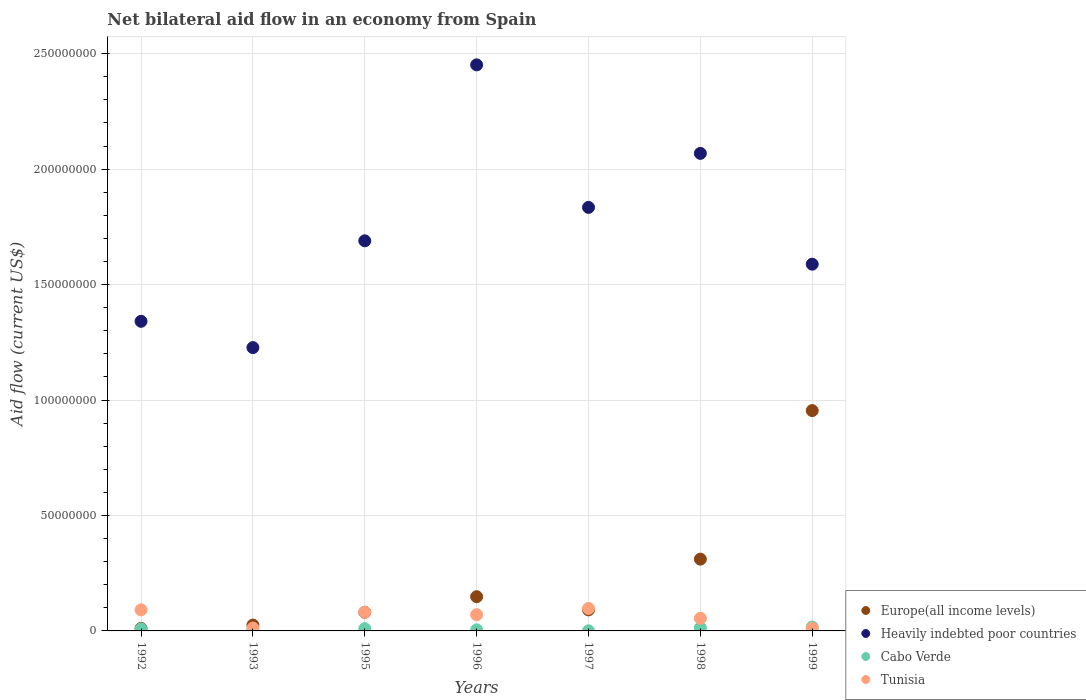How many different coloured dotlines are there?
Your answer should be compact. 4. What is the net bilateral aid flow in Europe(all income levels) in 1998?
Provide a succinct answer. 3.11e+07. Across all years, what is the maximum net bilateral aid flow in Tunisia?
Ensure brevity in your answer.  9.73e+06. Across all years, what is the minimum net bilateral aid flow in Europe(all income levels)?
Make the answer very short. 1.11e+06. In which year was the net bilateral aid flow in Heavily indebted poor countries maximum?
Ensure brevity in your answer.  1996. What is the total net bilateral aid flow in Cabo Verde in the graph?
Your answer should be very brief. 5.86e+06. What is the difference between the net bilateral aid flow in Heavily indebted poor countries in 1993 and that in 1995?
Your answer should be very brief. -4.62e+07. What is the difference between the net bilateral aid flow in Europe(all income levels) in 1993 and the net bilateral aid flow in Tunisia in 1992?
Your response must be concise. -6.59e+06. What is the average net bilateral aid flow in Tunisia per year?
Keep it short and to the point. 5.98e+06. In the year 1997, what is the difference between the net bilateral aid flow in Heavily indebted poor countries and net bilateral aid flow in Tunisia?
Offer a very short reply. 1.74e+08. In how many years, is the net bilateral aid flow in Heavily indebted poor countries greater than 70000000 US$?
Offer a very short reply. 7. What is the ratio of the net bilateral aid flow in Cabo Verde in 1996 to that in 1998?
Make the answer very short. 0.34. Is the difference between the net bilateral aid flow in Heavily indebted poor countries in 1997 and 1998 greater than the difference between the net bilateral aid flow in Tunisia in 1997 and 1998?
Make the answer very short. No. What is the difference between the highest and the second highest net bilateral aid flow in Cabo Verde?
Your answer should be compact. 3.10e+05. What is the difference between the highest and the lowest net bilateral aid flow in Heavily indebted poor countries?
Make the answer very short. 1.22e+08. Is the sum of the net bilateral aid flow in Europe(all income levels) in 1995 and 1996 greater than the maximum net bilateral aid flow in Heavily indebted poor countries across all years?
Offer a very short reply. No. Is it the case that in every year, the sum of the net bilateral aid flow in Heavily indebted poor countries and net bilateral aid flow in Tunisia  is greater than the sum of net bilateral aid flow in Cabo Verde and net bilateral aid flow in Europe(all income levels)?
Your response must be concise. Yes. Is it the case that in every year, the sum of the net bilateral aid flow in Tunisia and net bilateral aid flow in Europe(all income levels)  is greater than the net bilateral aid flow in Cabo Verde?
Your response must be concise. Yes. Does the net bilateral aid flow in Heavily indebted poor countries monotonically increase over the years?
Ensure brevity in your answer.  No. Is the net bilateral aid flow in Heavily indebted poor countries strictly greater than the net bilateral aid flow in Tunisia over the years?
Keep it short and to the point. Yes. How many dotlines are there?
Your answer should be very brief. 4. How many years are there in the graph?
Keep it short and to the point. 7. What is the difference between two consecutive major ticks on the Y-axis?
Ensure brevity in your answer.  5.00e+07. Are the values on the major ticks of Y-axis written in scientific E-notation?
Make the answer very short. No. Does the graph contain any zero values?
Offer a very short reply. No. Does the graph contain grids?
Provide a short and direct response. Yes. What is the title of the graph?
Your response must be concise. Net bilateral aid flow in an economy from Spain. What is the label or title of the Y-axis?
Give a very brief answer. Aid flow (current US$). What is the Aid flow (current US$) of Europe(all income levels) in 1992?
Keep it short and to the point. 1.11e+06. What is the Aid flow (current US$) in Heavily indebted poor countries in 1992?
Your answer should be compact. 1.34e+08. What is the Aid flow (current US$) of Cabo Verde in 1992?
Offer a terse response. 8.80e+05. What is the Aid flow (current US$) in Tunisia in 1992?
Make the answer very short. 9.13e+06. What is the Aid flow (current US$) of Europe(all income levels) in 1993?
Your answer should be very brief. 2.54e+06. What is the Aid flow (current US$) of Heavily indebted poor countries in 1993?
Your answer should be compact. 1.23e+08. What is the Aid flow (current US$) in Tunisia in 1993?
Keep it short and to the point. 1.25e+06. What is the Aid flow (current US$) in Europe(all income levels) in 1995?
Offer a terse response. 8.07e+06. What is the Aid flow (current US$) in Heavily indebted poor countries in 1995?
Offer a very short reply. 1.69e+08. What is the Aid flow (current US$) in Cabo Verde in 1995?
Offer a terse response. 9.90e+05. What is the Aid flow (current US$) of Tunisia in 1995?
Your response must be concise. 8.09e+06. What is the Aid flow (current US$) in Europe(all income levels) in 1996?
Ensure brevity in your answer.  1.48e+07. What is the Aid flow (current US$) of Heavily indebted poor countries in 1996?
Your answer should be very brief. 2.45e+08. What is the Aid flow (current US$) in Tunisia in 1996?
Your answer should be compact. 7.03e+06. What is the Aid flow (current US$) of Europe(all income levels) in 1997?
Make the answer very short. 9.11e+06. What is the Aid flow (current US$) of Heavily indebted poor countries in 1997?
Keep it short and to the point. 1.83e+08. What is the Aid flow (current US$) of Cabo Verde in 1997?
Your answer should be compact. 5.00e+04. What is the Aid flow (current US$) of Tunisia in 1997?
Make the answer very short. 9.73e+06. What is the Aid flow (current US$) of Europe(all income levels) in 1998?
Give a very brief answer. 3.11e+07. What is the Aid flow (current US$) in Heavily indebted poor countries in 1998?
Ensure brevity in your answer.  2.07e+08. What is the Aid flow (current US$) in Cabo Verde in 1998?
Make the answer very short. 1.37e+06. What is the Aid flow (current US$) in Tunisia in 1998?
Offer a terse response. 5.47e+06. What is the Aid flow (current US$) in Europe(all income levels) in 1999?
Provide a short and direct response. 9.54e+07. What is the Aid flow (current US$) in Heavily indebted poor countries in 1999?
Offer a very short reply. 1.59e+08. What is the Aid flow (current US$) of Cabo Verde in 1999?
Keep it short and to the point. 1.68e+06. What is the Aid flow (current US$) in Tunisia in 1999?
Make the answer very short. 1.13e+06. Across all years, what is the maximum Aid flow (current US$) of Europe(all income levels)?
Keep it short and to the point. 9.54e+07. Across all years, what is the maximum Aid flow (current US$) of Heavily indebted poor countries?
Make the answer very short. 2.45e+08. Across all years, what is the maximum Aid flow (current US$) of Cabo Verde?
Make the answer very short. 1.68e+06. Across all years, what is the maximum Aid flow (current US$) in Tunisia?
Your answer should be very brief. 9.73e+06. Across all years, what is the minimum Aid flow (current US$) in Europe(all income levels)?
Your response must be concise. 1.11e+06. Across all years, what is the minimum Aid flow (current US$) of Heavily indebted poor countries?
Make the answer very short. 1.23e+08. Across all years, what is the minimum Aid flow (current US$) of Tunisia?
Your answer should be compact. 1.13e+06. What is the total Aid flow (current US$) of Europe(all income levels) in the graph?
Offer a very short reply. 1.62e+08. What is the total Aid flow (current US$) of Heavily indebted poor countries in the graph?
Ensure brevity in your answer.  1.22e+09. What is the total Aid flow (current US$) in Cabo Verde in the graph?
Keep it short and to the point. 5.86e+06. What is the total Aid flow (current US$) in Tunisia in the graph?
Give a very brief answer. 4.18e+07. What is the difference between the Aid flow (current US$) in Europe(all income levels) in 1992 and that in 1993?
Your response must be concise. -1.43e+06. What is the difference between the Aid flow (current US$) in Heavily indebted poor countries in 1992 and that in 1993?
Your answer should be very brief. 1.14e+07. What is the difference between the Aid flow (current US$) in Cabo Verde in 1992 and that in 1993?
Offer a terse response. 4.50e+05. What is the difference between the Aid flow (current US$) in Tunisia in 1992 and that in 1993?
Your answer should be very brief. 7.88e+06. What is the difference between the Aid flow (current US$) of Europe(all income levels) in 1992 and that in 1995?
Keep it short and to the point. -6.96e+06. What is the difference between the Aid flow (current US$) of Heavily indebted poor countries in 1992 and that in 1995?
Give a very brief answer. -3.49e+07. What is the difference between the Aid flow (current US$) in Tunisia in 1992 and that in 1995?
Offer a very short reply. 1.04e+06. What is the difference between the Aid flow (current US$) of Europe(all income levels) in 1992 and that in 1996?
Your answer should be very brief. -1.37e+07. What is the difference between the Aid flow (current US$) of Heavily indebted poor countries in 1992 and that in 1996?
Provide a succinct answer. -1.11e+08. What is the difference between the Aid flow (current US$) of Cabo Verde in 1992 and that in 1996?
Offer a terse response. 4.20e+05. What is the difference between the Aid flow (current US$) in Tunisia in 1992 and that in 1996?
Make the answer very short. 2.10e+06. What is the difference between the Aid flow (current US$) in Europe(all income levels) in 1992 and that in 1997?
Your response must be concise. -8.00e+06. What is the difference between the Aid flow (current US$) of Heavily indebted poor countries in 1992 and that in 1997?
Your response must be concise. -4.93e+07. What is the difference between the Aid flow (current US$) in Cabo Verde in 1992 and that in 1997?
Give a very brief answer. 8.30e+05. What is the difference between the Aid flow (current US$) of Tunisia in 1992 and that in 1997?
Provide a short and direct response. -6.00e+05. What is the difference between the Aid flow (current US$) in Europe(all income levels) in 1992 and that in 1998?
Ensure brevity in your answer.  -3.00e+07. What is the difference between the Aid flow (current US$) of Heavily indebted poor countries in 1992 and that in 1998?
Your answer should be very brief. -7.27e+07. What is the difference between the Aid flow (current US$) in Cabo Verde in 1992 and that in 1998?
Your response must be concise. -4.90e+05. What is the difference between the Aid flow (current US$) of Tunisia in 1992 and that in 1998?
Your response must be concise. 3.66e+06. What is the difference between the Aid flow (current US$) in Europe(all income levels) in 1992 and that in 1999?
Provide a succinct answer. -9.43e+07. What is the difference between the Aid flow (current US$) in Heavily indebted poor countries in 1992 and that in 1999?
Give a very brief answer. -2.47e+07. What is the difference between the Aid flow (current US$) of Cabo Verde in 1992 and that in 1999?
Make the answer very short. -8.00e+05. What is the difference between the Aid flow (current US$) of Europe(all income levels) in 1993 and that in 1995?
Your answer should be very brief. -5.53e+06. What is the difference between the Aid flow (current US$) of Heavily indebted poor countries in 1993 and that in 1995?
Give a very brief answer. -4.62e+07. What is the difference between the Aid flow (current US$) of Cabo Verde in 1993 and that in 1995?
Provide a short and direct response. -5.60e+05. What is the difference between the Aid flow (current US$) in Tunisia in 1993 and that in 1995?
Offer a very short reply. -6.84e+06. What is the difference between the Aid flow (current US$) in Europe(all income levels) in 1993 and that in 1996?
Your response must be concise. -1.23e+07. What is the difference between the Aid flow (current US$) of Heavily indebted poor countries in 1993 and that in 1996?
Offer a terse response. -1.22e+08. What is the difference between the Aid flow (current US$) of Cabo Verde in 1993 and that in 1996?
Provide a short and direct response. -3.00e+04. What is the difference between the Aid flow (current US$) of Tunisia in 1993 and that in 1996?
Your answer should be very brief. -5.78e+06. What is the difference between the Aid flow (current US$) in Europe(all income levels) in 1993 and that in 1997?
Make the answer very short. -6.57e+06. What is the difference between the Aid flow (current US$) of Heavily indebted poor countries in 1993 and that in 1997?
Your response must be concise. -6.07e+07. What is the difference between the Aid flow (current US$) of Cabo Verde in 1993 and that in 1997?
Offer a very short reply. 3.80e+05. What is the difference between the Aid flow (current US$) in Tunisia in 1993 and that in 1997?
Your answer should be compact. -8.48e+06. What is the difference between the Aid flow (current US$) of Europe(all income levels) in 1993 and that in 1998?
Provide a succinct answer. -2.86e+07. What is the difference between the Aid flow (current US$) in Heavily indebted poor countries in 1993 and that in 1998?
Provide a short and direct response. -8.41e+07. What is the difference between the Aid flow (current US$) in Cabo Verde in 1993 and that in 1998?
Provide a short and direct response. -9.40e+05. What is the difference between the Aid flow (current US$) of Tunisia in 1993 and that in 1998?
Ensure brevity in your answer.  -4.22e+06. What is the difference between the Aid flow (current US$) of Europe(all income levels) in 1993 and that in 1999?
Offer a terse response. -9.29e+07. What is the difference between the Aid flow (current US$) of Heavily indebted poor countries in 1993 and that in 1999?
Ensure brevity in your answer.  -3.61e+07. What is the difference between the Aid flow (current US$) in Cabo Verde in 1993 and that in 1999?
Give a very brief answer. -1.25e+06. What is the difference between the Aid flow (current US$) in Europe(all income levels) in 1995 and that in 1996?
Your answer should be very brief. -6.76e+06. What is the difference between the Aid flow (current US$) of Heavily indebted poor countries in 1995 and that in 1996?
Ensure brevity in your answer.  -7.62e+07. What is the difference between the Aid flow (current US$) of Cabo Verde in 1995 and that in 1996?
Keep it short and to the point. 5.30e+05. What is the difference between the Aid flow (current US$) of Tunisia in 1995 and that in 1996?
Your response must be concise. 1.06e+06. What is the difference between the Aid flow (current US$) of Europe(all income levels) in 1995 and that in 1997?
Provide a short and direct response. -1.04e+06. What is the difference between the Aid flow (current US$) in Heavily indebted poor countries in 1995 and that in 1997?
Provide a succinct answer. -1.45e+07. What is the difference between the Aid flow (current US$) of Cabo Verde in 1995 and that in 1997?
Your response must be concise. 9.40e+05. What is the difference between the Aid flow (current US$) of Tunisia in 1995 and that in 1997?
Your answer should be very brief. -1.64e+06. What is the difference between the Aid flow (current US$) in Europe(all income levels) in 1995 and that in 1998?
Make the answer very short. -2.30e+07. What is the difference between the Aid flow (current US$) of Heavily indebted poor countries in 1995 and that in 1998?
Provide a short and direct response. -3.79e+07. What is the difference between the Aid flow (current US$) of Cabo Verde in 1995 and that in 1998?
Your answer should be very brief. -3.80e+05. What is the difference between the Aid flow (current US$) in Tunisia in 1995 and that in 1998?
Keep it short and to the point. 2.62e+06. What is the difference between the Aid flow (current US$) of Europe(all income levels) in 1995 and that in 1999?
Provide a succinct answer. -8.74e+07. What is the difference between the Aid flow (current US$) in Heavily indebted poor countries in 1995 and that in 1999?
Your answer should be compact. 1.01e+07. What is the difference between the Aid flow (current US$) in Cabo Verde in 1995 and that in 1999?
Provide a succinct answer. -6.90e+05. What is the difference between the Aid flow (current US$) in Tunisia in 1995 and that in 1999?
Your answer should be compact. 6.96e+06. What is the difference between the Aid flow (current US$) of Europe(all income levels) in 1996 and that in 1997?
Provide a succinct answer. 5.72e+06. What is the difference between the Aid flow (current US$) in Heavily indebted poor countries in 1996 and that in 1997?
Your answer should be compact. 6.17e+07. What is the difference between the Aid flow (current US$) of Cabo Verde in 1996 and that in 1997?
Your answer should be very brief. 4.10e+05. What is the difference between the Aid flow (current US$) of Tunisia in 1996 and that in 1997?
Your answer should be very brief. -2.70e+06. What is the difference between the Aid flow (current US$) of Europe(all income levels) in 1996 and that in 1998?
Offer a terse response. -1.63e+07. What is the difference between the Aid flow (current US$) in Heavily indebted poor countries in 1996 and that in 1998?
Keep it short and to the point. 3.83e+07. What is the difference between the Aid flow (current US$) in Cabo Verde in 1996 and that in 1998?
Your response must be concise. -9.10e+05. What is the difference between the Aid flow (current US$) of Tunisia in 1996 and that in 1998?
Make the answer very short. 1.56e+06. What is the difference between the Aid flow (current US$) in Europe(all income levels) in 1996 and that in 1999?
Keep it short and to the point. -8.06e+07. What is the difference between the Aid flow (current US$) of Heavily indebted poor countries in 1996 and that in 1999?
Keep it short and to the point. 8.63e+07. What is the difference between the Aid flow (current US$) of Cabo Verde in 1996 and that in 1999?
Provide a short and direct response. -1.22e+06. What is the difference between the Aid flow (current US$) in Tunisia in 1996 and that in 1999?
Provide a succinct answer. 5.90e+06. What is the difference between the Aid flow (current US$) of Europe(all income levels) in 1997 and that in 1998?
Your answer should be compact. -2.20e+07. What is the difference between the Aid flow (current US$) in Heavily indebted poor countries in 1997 and that in 1998?
Give a very brief answer. -2.34e+07. What is the difference between the Aid flow (current US$) in Cabo Verde in 1997 and that in 1998?
Offer a very short reply. -1.32e+06. What is the difference between the Aid flow (current US$) of Tunisia in 1997 and that in 1998?
Your answer should be compact. 4.26e+06. What is the difference between the Aid flow (current US$) in Europe(all income levels) in 1997 and that in 1999?
Provide a short and direct response. -8.63e+07. What is the difference between the Aid flow (current US$) in Heavily indebted poor countries in 1997 and that in 1999?
Keep it short and to the point. 2.46e+07. What is the difference between the Aid flow (current US$) of Cabo Verde in 1997 and that in 1999?
Ensure brevity in your answer.  -1.63e+06. What is the difference between the Aid flow (current US$) in Tunisia in 1997 and that in 1999?
Your response must be concise. 8.60e+06. What is the difference between the Aid flow (current US$) of Europe(all income levels) in 1998 and that in 1999?
Give a very brief answer. -6.43e+07. What is the difference between the Aid flow (current US$) of Heavily indebted poor countries in 1998 and that in 1999?
Keep it short and to the point. 4.80e+07. What is the difference between the Aid flow (current US$) in Cabo Verde in 1998 and that in 1999?
Ensure brevity in your answer.  -3.10e+05. What is the difference between the Aid flow (current US$) in Tunisia in 1998 and that in 1999?
Give a very brief answer. 4.34e+06. What is the difference between the Aid flow (current US$) of Europe(all income levels) in 1992 and the Aid flow (current US$) of Heavily indebted poor countries in 1993?
Your answer should be compact. -1.22e+08. What is the difference between the Aid flow (current US$) in Europe(all income levels) in 1992 and the Aid flow (current US$) in Cabo Verde in 1993?
Offer a terse response. 6.80e+05. What is the difference between the Aid flow (current US$) in Heavily indebted poor countries in 1992 and the Aid flow (current US$) in Cabo Verde in 1993?
Offer a terse response. 1.34e+08. What is the difference between the Aid flow (current US$) in Heavily indebted poor countries in 1992 and the Aid flow (current US$) in Tunisia in 1993?
Your response must be concise. 1.33e+08. What is the difference between the Aid flow (current US$) in Cabo Verde in 1992 and the Aid flow (current US$) in Tunisia in 1993?
Offer a terse response. -3.70e+05. What is the difference between the Aid flow (current US$) of Europe(all income levels) in 1992 and the Aid flow (current US$) of Heavily indebted poor countries in 1995?
Your answer should be very brief. -1.68e+08. What is the difference between the Aid flow (current US$) of Europe(all income levels) in 1992 and the Aid flow (current US$) of Cabo Verde in 1995?
Offer a terse response. 1.20e+05. What is the difference between the Aid flow (current US$) of Europe(all income levels) in 1992 and the Aid flow (current US$) of Tunisia in 1995?
Your response must be concise. -6.98e+06. What is the difference between the Aid flow (current US$) in Heavily indebted poor countries in 1992 and the Aid flow (current US$) in Cabo Verde in 1995?
Give a very brief answer. 1.33e+08. What is the difference between the Aid flow (current US$) of Heavily indebted poor countries in 1992 and the Aid flow (current US$) of Tunisia in 1995?
Your answer should be compact. 1.26e+08. What is the difference between the Aid flow (current US$) of Cabo Verde in 1992 and the Aid flow (current US$) of Tunisia in 1995?
Give a very brief answer. -7.21e+06. What is the difference between the Aid flow (current US$) in Europe(all income levels) in 1992 and the Aid flow (current US$) in Heavily indebted poor countries in 1996?
Make the answer very short. -2.44e+08. What is the difference between the Aid flow (current US$) of Europe(all income levels) in 1992 and the Aid flow (current US$) of Cabo Verde in 1996?
Your response must be concise. 6.50e+05. What is the difference between the Aid flow (current US$) of Europe(all income levels) in 1992 and the Aid flow (current US$) of Tunisia in 1996?
Your answer should be compact. -5.92e+06. What is the difference between the Aid flow (current US$) of Heavily indebted poor countries in 1992 and the Aid flow (current US$) of Cabo Verde in 1996?
Provide a succinct answer. 1.34e+08. What is the difference between the Aid flow (current US$) in Heavily indebted poor countries in 1992 and the Aid flow (current US$) in Tunisia in 1996?
Your response must be concise. 1.27e+08. What is the difference between the Aid flow (current US$) of Cabo Verde in 1992 and the Aid flow (current US$) of Tunisia in 1996?
Provide a short and direct response. -6.15e+06. What is the difference between the Aid flow (current US$) of Europe(all income levels) in 1992 and the Aid flow (current US$) of Heavily indebted poor countries in 1997?
Give a very brief answer. -1.82e+08. What is the difference between the Aid flow (current US$) in Europe(all income levels) in 1992 and the Aid flow (current US$) in Cabo Verde in 1997?
Make the answer very short. 1.06e+06. What is the difference between the Aid flow (current US$) of Europe(all income levels) in 1992 and the Aid flow (current US$) of Tunisia in 1997?
Provide a succinct answer. -8.62e+06. What is the difference between the Aid flow (current US$) of Heavily indebted poor countries in 1992 and the Aid flow (current US$) of Cabo Verde in 1997?
Offer a terse response. 1.34e+08. What is the difference between the Aid flow (current US$) in Heavily indebted poor countries in 1992 and the Aid flow (current US$) in Tunisia in 1997?
Offer a very short reply. 1.24e+08. What is the difference between the Aid flow (current US$) of Cabo Verde in 1992 and the Aid flow (current US$) of Tunisia in 1997?
Provide a succinct answer. -8.85e+06. What is the difference between the Aid flow (current US$) of Europe(all income levels) in 1992 and the Aid flow (current US$) of Heavily indebted poor countries in 1998?
Give a very brief answer. -2.06e+08. What is the difference between the Aid flow (current US$) in Europe(all income levels) in 1992 and the Aid flow (current US$) in Tunisia in 1998?
Provide a succinct answer. -4.36e+06. What is the difference between the Aid flow (current US$) in Heavily indebted poor countries in 1992 and the Aid flow (current US$) in Cabo Verde in 1998?
Provide a succinct answer. 1.33e+08. What is the difference between the Aid flow (current US$) of Heavily indebted poor countries in 1992 and the Aid flow (current US$) of Tunisia in 1998?
Provide a succinct answer. 1.29e+08. What is the difference between the Aid flow (current US$) of Cabo Verde in 1992 and the Aid flow (current US$) of Tunisia in 1998?
Provide a succinct answer. -4.59e+06. What is the difference between the Aid flow (current US$) in Europe(all income levels) in 1992 and the Aid flow (current US$) in Heavily indebted poor countries in 1999?
Give a very brief answer. -1.58e+08. What is the difference between the Aid flow (current US$) in Europe(all income levels) in 1992 and the Aid flow (current US$) in Cabo Verde in 1999?
Provide a short and direct response. -5.70e+05. What is the difference between the Aid flow (current US$) in Heavily indebted poor countries in 1992 and the Aid flow (current US$) in Cabo Verde in 1999?
Make the answer very short. 1.32e+08. What is the difference between the Aid flow (current US$) of Heavily indebted poor countries in 1992 and the Aid flow (current US$) of Tunisia in 1999?
Provide a succinct answer. 1.33e+08. What is the difference between the Aid flow (current US$) in Cabo Verde in 1992 and the Aid flow (current US$) in Tunisia in 1999?
Give a very brief answer. -2.50e+05. What is the difference between the Aid flow (current US$) of Europe(all income levels) in 1993 and the Aid flow (current US$) of Heavily indebted poor countries in 1995?
Offer a very short reply. -1.66e+08. What is the difference between the Aid flow (current US$) of Europe(all income levels) in 1993 and the Aid flow (current US$) of Cabo Verde in 1995?
Your answer should be compact. 1.55e+06. What is the difference between the Aid flow (current US$) of Europe(all income levels) in 1993 and the Aid flow (current US$) of Tunisia in 1995?
Offer a terse response. -5.55e+06. What is the difference between the Aid flow (current US$) of Heavily indebted poor countries in 1993 and the Aid flow (current US$) of Cabo Verde in 1995?
Provide a succinct answer. 1.22e+08. What is the difference between the Aid flow (current US$) in Heavily indebted poor countries in 1993 and the Aid flow (current US$) in Tunisia in 1995?
Ensure brevity in your answer.  1.15e+08. What is the difference between the Aid flow (current US$) in Cabo Verde in 1993 and the Aid flow (current US$) in Tunisia in 1995?
Offer a very short reply. -7.66e+06. What is the difference between the Aid flow (current US$) in Europe(all income levels) in 1993 and the Aid flow (current US$) in Heavily indebted poor countries in 1996?
Make the answer very short. -2.43e+08. What is the difference between the Aid flow (current US$) of Europe(all income levels) in 1993 and the Aid flow (current US$) of Cabo Verde in 1996?
Provide a short and direct response. 2.08e+06. What is the difference between the Aid flow (current US$) in Europe(all income levels) in 1993 and the Aid flow (current US$) in Tunisia in 1996?
Your response must be concise. -4.49e+06. What is the difference between the Aid flow (current US$) in Heavily indebted poor countries in 1993 and the Aid flow (current US$) in Cabo Verde in 1996?
Offer a very short reply. 1.22e+08. What is the difference between the Aid flow (current US$) in Heavily indebted poor countries in 1993 and the Aid flow (current US$) in Tunisia in 1996?
Your answer should be compact. 1.16e+08. What is the difference between the Aid flow (current US$) in Cabo Verde in 1993 and the Aid flow (current US$) in Tunisia in 1996?
Provide a short and direct response. -6.60e+06. What is the difference between the Aid flow (current US$) of Europe(all income levels) in 1993 and the Aid flow (current US$) of Heavily indebted poor countries in 1997?
Ensure brevity in your answer.  -1.81e+08. What is the difference between the Aid flow (current US$) in Europe(all income levels) in 1993 and the Aid flow (current US$) in Cabo Verde in 1997?
Ensure brevity in your answer.  2.49e+06. What is the difference between the Aid flow (current US$) of Europe(all income levels) in 1993 and the Aid flow (current US$) of Tunisia in 1997?
Keep it short and to the point. -7.19e+06. What is the difference between the Aid flow (current US$) of Heavily indebted poor countries in 1993 and the Aid flow (current US$) of Cabo Verde in 1997?
Offer a very short reply. 1.23e+08. What is the difference between the Aid flow (current US$) of Heavily indebted poor countries in 1993 and the Aid flow (current US$) of Tunisia in 1997?
Offer a very short reply. 1.13e+08. What is the difference between the Aid flow (current US$) of Cabo Verde in 1993 and the Aid flow (current US$) of Tunisia in 1997?
Ensure brevity in your answer.  -9.30e+06. What is the difference between the Aid flow (current US$) of Europe(all income levels) in 1993 and the Aid flow (current US$) of Heavily indebted poor countries in 1998?
Offer a terse response. -2.04e+08. What is the difference between the Aid flow (current US$) of Europe(all income levels) in 1993 and the Aid flow (current US$) of Cabo Verde in 1998?
Give a very brief answer. 1.17e+06. What is the difference between the Aid flow (current US$) of Europe(all income levels) in 1993 and the Aid flow (current US$) of Tunisia in 1998?
Ensure brevity in your answer.  -2.93e+06. What is the difference between the Aid flow (current US$) in Heavily indebted poor countries in 1993 and the Aid flow (current US$) in Cabo Verde in 1998?
Provide a short and direct response. 1.21e+08. What is the difference between the Aid flow (current US$) of Heavily indebted poor countries in 1993 and the Aid flow (current US$) of Tunisia in 1998?
Offer a very short reply. 1.17e+08. What is the difference between the Aid flow (current US$) in Cabo Verde in 1993 and the Aid flow (current US$) in Tunisia in 1998?
Your answer should be very brief. -5.04e+06. What is the difference between the Aid flow (current US$) of Europe(all income levels) in 1993 and the Aid flow (current US$) of Heavily indebted poor countries in 1999?
Your answer should be compact. -1.56e+08. What is the difference between the Aid flow (current US$) in Europe(all income levels) in 1993 and the Aid flow (current US$) in Cabo Verde in 1999?
Provide a short and direct response. 8.60e+05. What is the difference between the Aid flow (current US$) of Europe(all income levels) in 1993 and the Aid flow (current US$) of Tunisia in 1999?
Provide a succinct answer. 1.41e+06. What is the difference between the Aid flow (current US$) of Heavily indebted poor countries in 1993 and the Aid flow (current US$) of Cabo Verde in 1999?
Give a very brief answer. 1.21e+08. What is the difference between the Aid flow (current US$) of Heavily indebted poor countries in 1993 and the Aid flow (current US$) of Tunisia in 1999?
Provide a succinct answer. 1.22e+08. What is the difference between the Aid flow (current US$) of Cabo Verde in 1993 and the Aid flow (current US$) of Tunisia in 1999?
Make the answer very short. -7.00e+05. What is the difference between the Aid flow (current US$) of Europe(all income levels) in 1995 and the Aid flow (current US$) of Heavily indebted poor countries in 1996?
Keep it short and to the point. -2.37e+08. What is the difference between the Aid flow (current US$) of Europe(all income levels) in 1995 and the Aid flow (current US$) of Cabo Verde in 1996?
Provide a short and direct response. 7.61e+06. What is the difference between the Aid flow (current US$) in Europe(all income levels) in 1995 and the Aid flow (current US$) in Tunisia in 1996?
Offer a terse response. 1.04e+06. What is the difference between the Aid flow (current US$) of Heavily indebted poor countries in 1995 and the Aid flow (current US$) of Cabo Verde in 1996?
Make the answer very short. 1.68e+08. What is the difference between the Aid flow (current US$) of Heavily indebted poor countries in 1995 and the Aid flow (current US$) of Tunisia in 1996?
Offer a terse response. 1.62e+08. What is the difference between the Aid flow (current US$) of Cabo Verde in 1995 and the Aid flow (current US$) of Tunisia in 1996?
Provide a succinct answer. -6.04e+06. What is the difference between the Aid flow (current US$) of Europe(all income levels) in 1995 and the Aid flow (current US$) of Heavily indebted poor countries in 1997?
Offer a terse response. -1.75e+08. What is the difference between the Aid flow (current US$) of Europe(all income levels) in 1995 and the Aid flow (current US$) of Cabo Verde in 1997?
Your answer should be compact. 8.02e+06. What is the difference between the Aid flow (current US$) in Europe(all income levels) in 1995 and the Aid flow (current US$) in Tunisia in 1997?
Your answer should be very brief. -1.66e+06. What is the difference between the Aid flow (current US$) of Heavily indebted poor countries in 1995 and the Aid flow (current US$) of Cabo Verde in 1997?
Make the answer very short. 1.69e+08. What is the difference between the Aid flow (current US$) of Heavily indebted poor countries in 1995 and the Aid flow (current US$) of Tunisia in 1997?
Your answer should be compact. 1.59e+08. What is the difference between the Aid flow (current US$) of Cabo Verde in 1995 and the Aid flow (current US$) of Tunisia in 1997?
Keep it short and to the point. -8.74e+06. What is the difference between the Aid flow (current US$) in Europe(all income levels) in 1995 and the Aid flow (current US$) in Heavily indebted poor countries in 1998?
Your answer should be compact. -1.99e+08. What is the difference between the Aid flow (current US$) in Europe(all income levels) in 1995 and the Aid flow (current US$) in Cabo Verde in 1998?
Make the answer very short. 6.70e+06. What is the difference between the Aid flow (current US$) of Europe(all income levels) in 1995 and the Aid flow (current US$) of Tunisia in 1998?
Offer a terse response. 2.60e+06. What is the difference between the Aid flow (current US$) in Heavily indebted poor countries in 1995 and the Aid flow (current US$) in Cabo Verde in 1998?
Offer a terse response. 1.68e+08. What is the difference between the Aid flow (current US$) of Heavily indebted poor countries in 1995 and the Aid flow (current US$) of Tunisia in 1998?
Keep it short and to the point. 1.63e+08. What is the difference between the Aid flow (current US$) in Cabo Verde in 1995 and the Aid flow (current US$) in Tunisia in 1998?
Offer a terse response. -4.48e+06. What is the difference between the Aid flow (current US$) in Europe(all income levels) in 1995 and the Aid flow (current US$) in Heavily indebted poor countries in 1999?
Offer a terse response. -1.51e+08. What is the difference between the Aid flow (current US$) in Europe(all income levels) in 1995 and the Aid flow (current US$) in Cabo Verde in 1999?
Offer a terse response. 6.39e+06. What is the difference between the Aid flow (current US$) of Europe(all income levels) in 1995 and the Aid flow (current US$) of Tunisia in 1999?
Make the answer very short. 6.94e+06. What is the difference between the Aid flow (current US$) of Heavily indebted poor countries in 1995 and the Aid flow (current US$) of Cabo Verde in 1999?
Your response must be concise. 1.67e+08. What is the difference between the Aid flow (current US$) of Heavily indebted poor countries in 1995 and the Aid flow (current US$) of Tunisia in 1999?
Your answer should be compact. 1.68e+08. What is the difference between the Aid flow (current US$) of Cabo Verde in 1995 and the Aid flow (current US$) of Tunisia in 1999?
Keep it short and to the point. -1.40e+05. What is the difference between the Aid flow (current US$) of Europe(all income levels) in 1996 and the Aid flow (current US$) of Heavily indebted poor countries in 1997?
Make the answer very short. -1.69e+08. What is the difference between the Aid flow (current US$) in Europe(all income levels) in 1996 and the Aid flow (current US$) in Cabo Verde in 1997?
Provide a succinct answer. 1.48e+07. What is the difference between the Aid flow (current US$) of Europe(all income levels) in 1996 and the Aid flow (current US$) of Tunisia in 1997?
Keep it short and to the point. 5.10e+06. What is the difference between the Aid flow (current US$) of Heavily indebted poor countries in 1996 and the Aid flow (current US$) of Cabo Verde in 1997?
Provide a succinct answer. 2.45e+08. What is the difference between the Aid flow (current US$) in Heavily indebted poor countries in 1996 and the Aid flow (current US$) in Tunisia in 1997?
Keep it short and to the point. 2.35e+08. What is the difference between the Aid flow (current US$) in Cabo Verde in 1996 and the Aid flow (current US$) in Tunisia in 1997?
Give a very brief answer. -9.27e+06. What is the difference between the Aid flow (current US$) of Europe(all income levels) in 1996 and the Aid flow (current US$) of Heavily indebted poor countries in 1998?
Your answer should be compact. -1.92e+08. What is the difference between the Aid flow (current US$) in Europe(all income levels) in 1996 and the Aid flow (current US$) in Cabo Verde in 1998?
Your answer should be compact. 1.35e+07. What is the difference between the Aid flow (current US$) in Europe(all income levels) in 1996 and the Aid flow (current US$) in Tunisia in 1998?
Offer a very short reply. 9.36e+06. What is the difference between the Aid flow (current US$) of Heavily indebted poor countries in 1996 and the Aid flow (current US$) of Cabo Verde in 1998?
Your response must be concise. 2.44e+08. What is the difference between the Aid flow (current US$) of Heavily indebted poor countries in 1996 and the Aid flow (current US$) of Tunisia in 1998?
Offer a terse response. 2.40e+08. What is the difference between the Aid flow (current US$) of Cabo Verde in 1996 and the Aid flow (current US$) of Tunisia in 1998?
Provide a succinct answer. -5.01e+06. What is the difference between the Aid flow (current US$) of Europe(all income levels) in 1996 and the Aid flow (current US$) of Heavily indebted poor countries in 1999?
Make the answer very short. -1.44e+08. What is the difference between the Aid flow (current US$) in Europe(all income levels) in 1996 and the Aid flow (current US$) in Cabo Verde in 1999?
Your answer should be very brief. 1.32e+07. What is the difference between the Aid flow (current US$) of Europe(all income levels) in 1996 and the Aid flow (current US$) of Tunisia in 1999?
Provide a short and direct response. 1.37e+07. What is the difference between the Aid flow (current US$) of Heavily indebted poor countries in 1996 and the Aid flow (current US$) of Cabo Verde in 1999?
Give a very brief answer. 2.43e+08. What is the difference between the Aid flow (current US$) of Heavily indebted poor countries in 1996 and the Aid flow (current US$) of Tunisia in 1999?
Offer a terse response. 2.44e+08. What is the difference between the Aid flow (current US$) in Cabo Verde in 1996 and the Aid flow (current US$) in Tunisia in 1999?
Make the answer very short. -6.70e+05. What is the difference between the Aid flow (current US$) of Europe(all income levels) in 1997 and the Aid flow (current US$) of Heavily indebted poor countries in 1998?
Offer a terse response. -1.98e+08. What is the difference between the Aid flow (current US$) in Europe(all income levels) in 1997 and the Aid flow (current US$) in Cabo Verde in 1998?
Give a very brief answer. 7.74e+06. What is the difference between the Aid flow (current US$) of Europe(all income levels) in 1997 and the Aid flow (current US$) of Tunisia in 1998?
Make the answer very short. 3.64e+06. What is the difference between the Aid flow (current US$) of Heavily indebted poor countries in 1997 and the Aid flow (current US$) of Cabo Verde in 1998?
Your answer should be very brief. 1.82e+08. What is the difference between the Aid flow (current US$) in Heavily indebted poor countries in 1997 and the Aid flow (current US$) in Tunisia in 1998?
Offer a terse response. 1.78e+08. What is the difference between the Aid flow (current US$) of Cabo Verde in 1997 and the Aid flow (current US$) of Tunisia in 1998?
Ensure brevity in your answer.  -5.42e+06. What is the difference between the Aid flow (current US$) in Europe(all income levels) in 1997 and the Aid flow (current US$) in Heavily indebted poor countries in 1999?
Keep it short and to the point. -1.50e+08. What is the difference between the Aid flow (current US$) in Europe(all income levels) in 1997 and the Aid flow (current US$) in Cabo Verde in 1999?
Give a very brief answer. 7.43e+06. What is the difference between the Aid flow (current US$) in Europe(all income levels) in 1997 and the Aid flow (current US$) in Tunisia in 1999?
Provide a succinct answer. 7.98e+06. What is the difference between the Aid flow (current US$) in Heavily indebted poor countries in 1997 and the Aid flow (current US$) in Cabo Verde in 1999?
Offer a very short reply. 1.82e+08. What is the difference between the Aid flow (current US$) of Heavily indebted poor countries in 1997 and the Aid flow (current US$) of Tunisia in 1999?
Keep it short and to the point. 1.82e+08. What is the difference between the Aid flow (current US$) of Cabo Verde in 1997 and the Aid flow (current US$) of Tunisia in 1999?
Make the answer very short. -1.08e+06. What is the difference between the Aid flow (current US$) of Europe(all income levels) in 1998 and the Aid flow (current US$) of Heavily indebted poor countries in 1999?
Offer a terse response. -1.28e+08. What is the difference between the Aid flow (current US$) in Europe(all income levels) in 1998 and the Aid flow (current US$) in Cabo Verde in 1999?
Offer a terse response. 2.94e+07. What is the difference between the Aid flow (current US$) in Europe(all income levels) in 1998 and the Aid flow (current US$) in Tunisia in 1999?
Ensure brevity in your answer.  3.00e+07. What is the difference between the Aid flow (current US$) of Heavily indebted poor countries in 1998 and the Aid flow (current US$) of Cabo Verde in 1999?
Provide a succinct answer. 2.05e+08. What is the difference between the Aid flow (current US$) in Heavily indebted poor countries in 1998 and the Aid flow (current US$) in Tunisia in 1999?
Offer a terse response. 2.06e+08. What is the difference between the Aid flow (current US$) in Cabo Verde in 1998 and the Aid flow (current US$) in Tunisia in 1999?
Provide a succinct answer. 2.40e+05. What is the average Aid flow (current US$) of Europe(all income levels) per year?
Your response must be concise. 2.32e+07. What is the average Aid flow (current US$) of Heavily indebted poor countries per year?
Give a very brief answer. 1.74e+08. What is the average Aid flow (current US$) in Cabo Verde per year?
Offer a terse response. 8.37e+05. What is the average Aid flow (current US$) of Tunisia per year?
Your response must be concise. 5.98e+06. In the year 1992, what is the difference between the Aid flow (current US$) of Europe(all income levels) and Aid flow (current US$) of Heavily indebted poor countries?
Make the answer very short. -1.33e+08. In the year 1992, what is the difference between the Aid flow (current US$) of Europe(all income levels) and Aid flow (current US$) of Tunisia?
Offer a terse response. -8.02e+06. In the year 1992, what is the difference between the Aid flow (current US$) in Heavily indebted poor countries and Aid flow (current US$) in Cabo Verde?
Offer a terse response. 1.33e+08. In the year 1992, what is the difference between the Aid flow (current US$) of Heavily indebted poor countries and Aid flow (current US$) of Tunisia?
Provide a short and direct response. 1.25e+08. In the year 1992, what is the difference between the Aid flow (current US$) of Cabo Verde and Aid flow (current US$) of Tunisia?
Keep it short and to the point. -8.25e+06. In the year 1993, what is the difference between the Aid flow (current US$) of Europe(all income levels) and Aid flow (current US$) of Heavily indebted poor countries?
Offer a very short reply. -1.20e+08. In the year 1993, what is the difference between the Aid flow (current US$) of Europe(all income levels) and Aid flow (current US$) of Cabo Verde?
Provide a short and direct response. 2.11e+06. In the year 1993, what is the difference between the Aid flow (current US$) of Europe(all income levels) and Aid flow (current US$) of Tunisia?
Your answer should be compact. 1.29e+06. In the year 1993, what is the difference between the Aid flow (current US$) of Heavily indebted poor countries and Aid flow (current US$) of Cabo Verde?
Provide a succinct answer. 1.22e+08. In the year 1993, what is the difference between the Aid flow (current US$) in Heavily indebted poor countries and Aid flow (current US$) in Tunisia?
Your response must be concise. 1.21e+08. In the year 1993, what is the difference between the Aid flow (current US$) of Cabo Verde and Aid flow (current US$) of Tunisia?
Ensure brevity in your answer.  -8.20e+05. In the year 1995, what is the difference between the Aid flow (current US$) of Europe(all income levels) and Aid flow (current US$) of Heavily indebted poor countries?
Ensure brevity in your answer.  -1.61e+08. In the year 1995, what is the difference between the Aid flow (current US$) of Europe(all income levels) and Aid flow (current US$) of Cabo Verde?
Provide a succinct answer. 7.08e+06. In the year 1995, what is the difference between the Aid flow (current US$) of Europe(all income levels) and Aid flow (current US$) of Tunisia?
Make the answer very short. -2.00e+04. In the year 1995, what is the difference between the Aid flow (current US$) in Heavily indebted poor countries and Aid flow (current US$) in Cabo Verde?
Make the answer very short. 1.68e+08. In the year 1995, what is the difference between the Aid flow (current US$) in Heavily indebted poor countries and Aid flow (current US$) in Tunisia?
Keep it short and to the point. 1.61e+08. In the year 1995, what is the difference between the Aid flow (current US$) in Cabo Verde and Aid flow (current US$) in Tunisia?
Offer a very short reply. -7.10e+06. In the year 1996, what is the difference between the Aid flow (current US$) of Europe(all income levels) and Aid flow (current US$) of Heavily indebted poor countries?
Provide a short and direct response. -2.30e+08. In the year 1996, what is the difference between the Aid flow (current US$) of Europe(all income levels) and Aid flow (current US$) of Cabo Verde?
Provide a short and direct response. 1.44e+07. In the year 1996, what is the difference between the Aid flow (current US$) of Europe(all income levels) and Aid flow (current US$) of Tunisia?
Offer a terse response. 7.80e+06. In the year 1996, what is the difference between the Aid flow (current US$) of Heavily indebted poor countries and Aid flow (current US$) of Cabo Verde?
Offer a very short reply. 2.45e+08. In the year 1996, what is the difference between the Aid flow (current US$) in Heavily indebted poor countries and Aid flow (current US$) in Tunisia?
Make the answer very short. 2.38e+08. In the year 1996, what is the difference between the Aid flow (current US$) of Cabo Verde and Aid flow (current US$) of Tunisia?
Ensure brevity in your answer.  -6.57e+06. In the year 1997, what is the difference between the Aid flow (current US$) in Europe(all income levels) and Aid flow (current US$) in Heavily indebted poor countries?
Your response must be concise. -1.74e+08. In the year 1997, what is the difference between the Aid flow (current US$) in Europe(all income levels) and Aid flow (current US$) in Cabo Verde?
Provide a succinct answer. 9.06e+06. In the year 1997, what is the difference between the Aid flow (current US$) in Europe(all income levels) and Aid flow (current US$) in Tunisia?
Ensure brevity in your answer.  -6.20e+05. In the year 1997, what is the difference between the Aid flow (current US$) of Heavily indebted poor countries and Aid flow (current US$) of Cabo Verde?
Offer a very short reply. 1.83e+08. In the year 1997, what is the difference between the Aid flow (current US$) of Heavily indebted poor countries and Aid flow (current US$) of Tunisia?
Provide a succinct answer. 1.74e+08. In the year 1997, what is the difference between the Aid flow (current US$) of Cabo Verde and Aid flow (current US$) of Tunisia?
Offer a terse response. -9.68e+06. In the year 1998, what is the difference between the Aid flow (current US$) of Europe(all income levels) and Aid flow (current US$) of Heavily indebted poor countries?
Your answer should be very brief. -1.76e+08. In the year 1998, what is the difference between the Aid flow (current US$) of Europe(all income levels) and Aid flow (current US$) of Cabo Verde?
Ensure brevity in your answer.  2.97e+07. In the year 1998, what is the difference between the Aid flow (current US$) in Europe(all income levels) and Aid flow (current US$) in Tunisia?
Provide a short and direct response. 2.56e+07. In the year 1998, what is the difference between the Aid flow (current US$) of Heavily indebted poor countries and Aid flow (current US$) of Cabo Verde?
Keep it short and to the point. 2.05e+08. In the year 1998, what is the difference between the Aid flow (current US$) of Heavily indebted poor countries and Aid flow (current US$) of Tunisia?
Give a very brief answer. 2.01e+08. In the year 1998, what is the difference between the Aid flow (current US$) in Cabo Verde and Aid flow (current US$) in Tunisia?
Provide a succinct answer. -4.10e+06. In the year 1999, what is the difference between the Aid flow (current US$) of Europe(all income levels) and Aid flow (current US$) of Heavily indebted poor countries?
Make the answer very short. -6.34e+07. In the year 1999, what is the difference between the Aid flow (current US$) of Europe(all income levels) and Aid flow (current US$) of Cabo Verde?
Your answer should be very brief. 9.37e+07. In the year 1999, what is the difference between the Aid flow (current US$) in Europe(all income levels) and Aid flow (current US$) in Tunisia?
Offer a very short reply. 9.43e+07. In the year 1999, what is the difference between the Aid flow (current US$) in Heavily indebted poor countries and Aid flow (current US$) in Cabo Verde?
Your answer should be very brief. 1.57e+08. In the year 1999, what is the difference between the Aid flow (current US$) of Heavily indebted poor countries and Aid flow (current US$) of Tunisia?
Offer a very short reply. 1.58e+08. What is the ratio of the Aid flow (current US$) of Europe(all income levels) in 1992 to that in 1993?
Keep it short and to the point. 0.44. What is the ratio of the Aid flow (current US$) of Heavily indebted poor countries in 1992 to that in 1993?
Make the answer very short. 1.09. What is the ratio of the Aid flow (current US$) of Cabo Verde in 1992 to that in 1993?
Provide a short and direct response. 2.05. What is the ratio of the Aid flow (current US$) in Tunisia in 1992 to that in 1993?
Your answer should be very brief. 7.3. What is the ratio of the Aid flow (current US$) in Europe(all income levels) in 1992 to that in 1995?
Offer a terse response. 0.14. What is the ratio of the Aid flow (current US$) in Heavily indebted poor countries in 1992 to that in 1995?
Make the answer very short. 0.79. What is the ratio of the Aid flow (current US$) of Cabo Verde in 1992 to that in 1995?
Give a very brief answer. 0.89. What is the ratio of the Aid flow (current US$) of Tunisia in 1992 to that in 1995?
Offer a very short reply. 1.13. What is the ratio of the Aid flow (current US$) in Europe(all income levels) in 1992 to that in 1996?
Offer a terse response. 0.07. What is the ratio of the Aid flow (current US$) of Heavily indebted poor countries in 1992 to that in 1996?
Provide a succinct answer. 0.55. What is the ratio of the Aid flow (current US$) in Cabo Verde in 1992 to that in 1996?
Your answer should be compact. 1.91. What is the ratio of the Aid flow (current US$) in Tunisia in 1992 to that in 1996?
Make the answer very short. 1.3. What is the ratio of the Aid flow (current US$) in Europe(all income levels) in 1992 to that in 1997?
Your answer should be compact. 0.12. What is the ratio of the Aid flow (current US$) in Heavily indebted poor countries in 1992 to that in 1997?
Make the answer very short. 0.73. What is the ratio of the Aid flow (current US$) in Tunisia in 1992 to that in 1997?
Offer a very short reply. 0.94. What is the ratio of the Aid flow (current US$) of Europe(all income levels) in 1992 to that in 1998?
Keep it short and to the point. 0.04. What is the ratio of the Aid flow (current US$) in Heavily indebted poor countries in 1992 to that in 1998?
Ensure brevity in your answer.  0.65. What is the ratio of the Aid flow (current US$) in Cabo Verde in 1992 to that in 1998?
Offer a very short reply. 0.64. What is the ratio of the Aid flow (current US$) in Tunisia in 1992 to that in 1998?
Make the answer very short. 1.67. What is the ratio of the Aid flow (current US$) in Europe(all income levels) in 1992 to that in 1999?
Your answer should be compact. 0.01. What is the ratio of the Aid flow (current US$) in Heavily indebted poor countries in 1992 to that in 1999?
Offer a terse response. 0.84. What is the ratio of the Aid flow (current US$) in Cabo Verde in 1992 to that in 1999?
Keep it short and to the point. 0.52. What is the ratio of the Aid flow (current US$) of Tunisia in 1992 to that in 1999?
Your answer should be very brief. 8.08. What is the ratio of the Aid flow (current US$) in Europe(all income levels) in 1993 to that in 1995?
Provide a succinct answer. 0.31. What is the ratio of the Aid flow (current US$) in Heavily indebted poor countries in 1993 to that in 1995?
Your answer should be very brief. 0.73. What is the ratio of the Aid flow (current US$) in Cabo Verde in 1993 to that in 1995?
Your answer should be very brief. 0.43. What is the ratio of the Aid flow (current US$) of Tunisia in 1993 to that in 1995?
Provide a succinct answer. 0.15. What is the ratio of the Aid flow (current US$) of Europe(all income levels) in 1993 to that in 1996?
Your answer should be very brief. 0.17. What is the ratio of the Aid flow (current US$) of Heavily indebted poor countries in 1993 to that in 1996?
Ensure brevity in your answer.  0.5. What is the ratio of the Aid flow (current US$) of Cabo Verde in 1993 to that in 1996?
Offer a terse response. 0.93. What is the ratio of the Aid flow (current US$) of Tunisia in 1993 to that in 1996?
Provide a succinct answer. 0.18. What is the ratio of the Aid flow (current US$) in Europe(all income levels) in 1993 to that in 1997?
Keep it short and to the point. 0.28. What is the ratio of the Aid flow (current US$) in Heavily indebted poor countries in 1993 to that in 1997?
Your response must be concise. 0.67. What is the ratio of the Aid flow (current US$) of Cabo Verde in 1993 to that in 1997?
Your answer should be very brief. 8.6. What is the ratio of the Aid flow (current US$) of Tunisia in 1993 to that in 1997?
Keep it short and to the point. 0.13. What is the ratio of the Aid flow (current US$) of Europe(all income levels) in 1993 to that in 1998?
Provide a short and direct response. 0.08. What is the ratio of the Aid flow (current US$) in Heavily indebted poor countries in 1993 to that in 1998?
Provide a succinct answer. 0.59. What is the ratio of the Aid flow (current US$) of Cabo Verde in 1993 to that in 1998?
Provide a short and direct response. 0.31. What is the ratio of the Aid flow (current US$) of Tunisia in 1993 to that in 1998?
Your answer should be very brief. 0.23. What is the ratio of the Aid flow (current US$) in Europe(all income levels) in 1993 to that in 1999?
Give a very brief answer. 0.03. What is the ratio of the Aid flow (current US$) of Heavily indebted poor countries in 1993 to that in 1999?
Your response must be concise. 0.77. What is the ratio of the Aid flow (current US$) in Cabo Verde in 1993 to that in 1999?
Give a very brief answer. 0.26. What is the ratio of the Aid flow (current US$) of Tunisia in 1993 to that in 1999?
Ensure brevity in your answer.  1.11. What is the ratio of the Aid flow (current US$) in Europe(all income levels) in 1995 to that in 1996?
Your response must be concise. 0.54. What is the ratio of the Aid flow (current US$) in Heavily indebted poor countries in 1995 to that in 1996?
Your response must be concise. 0.69. What is the ratio of the Aid flow (current US$) of Cabo Verde in 1995 to that in 1996?
Make the answer very short. 2.15. What is the ratio of the Aid flow (current US$) in Tunisia in 1995 to that in 1996?
Provide a succinct answer. 1.15. What is the ratio of the Aid flow (current US$) of Europe(all income levels) in 1995 to that in 1997?
Your answer should be very brief. 0.89. What is the ratio of the Aid flow (current US$) of Heavily indebted poor countries in 1995 to that in 1997?
Keep it short and to the point. 0.92. What is the ratio of the Aid flow (current US$) of Cabo Verde in 1995 to that in 1997?
Your response must be concise. 19.8. What is the ratio of the Aid flow (current US$) in Tunisia in 1995 to that in 1997?
Make the answer very short. 0.83. What is the ratio of the Aid flow (current US$) in Europe(all income levels) in 1995 to that in 1998?
Offer a very short reply. 0.26. What is the ratio of the Aid flow (current US$) of Heavily indebted poor countries in 1995 to that in 1998?
Keep it short and to the point. 0.82. What is the ratio of the Aid flow (current US$) in Cabo Verde in 1995 to that in 1998?
Make the answer very short. 0.72. What is the ratio of the Aid flow (current US$) in Tunisia in 1995 to that in 1998?
Offer a very short reply. 1.48. What is the ratio of the Aid flow (current US$) of Europe(all income levels) in 1995 to that in 1999?
Ensure brevity in your answer.  0.08. What is the ratio of the Aid flow (current US$) in Heavily indebted poor countries in 1995 to that in 1999?
Ensure brevity in your answer.  1.06. What is the ratio of the Aid flow (current US$) of Cabo Verde in 1995 to that in 1999?
Your response must be concise. 0.59. What is the ratio of the Aid flow (current US$) in Tunisia in 1995 to that in 1999?
Your response must be concise. 7.16. What is the ratio of the Aid flow (current US$) in Europe(all income levels) in 1996 to that in 1997?
Offer a terse response. 1.63. What is the ratio of the Aid flow (current US$) in Heavily indebted poor countries in 1996 to that in 1997?
Offer a terse response. 1.34. What is the ratio of the Aid flow (current US$) of Tunisia in 1996 to that in 1997?
Make the answer very short. 0.72. What is the ratio of the Aid flow (current US$) of Europe(all income levels) in 1996 to that in 1998?
Keep it short and to the point. 0.48. What is the ratio of the Aid flow (current US$) of Heavily indebted poor countries in 1996 to that in 1998?
Give a very brief answer. 1.19. What is the ratio of the Aid flow (current US$) of Cabo Verde in 1996 to that in 1998?
Your answer should be compact. 0.34. What is the ratio of the Aid flow (current US$) in Tunisia in 1996 to that in 1998?
Make the answer very short. 1.29. What is the ratio of the Aid flow (current US$) in Europe(all income levels) in 1996 to that in 1999?
Make the answer very short. 0.16. What is the ratio of the Aid flow (current US$) in Heavily indebted poor countries in 1996 to that in 1999?
Keep it short and to the point. 1.54. What is the ratio of the Aid flow (current US$) of Cabo Verde in 1996 to that in 1999?
Your answer should be compact. 0.27. What is the ratio of the Aid flow (current US$) in Tunisia in 1996 to that in 1999?
Give a very brief answer. 6.22. What is the ratio of the Aid flow (current US$) in Europe(all income levels) in 1997 to that in 1998?
Provide a short and direct response. 0.29. What is the ratio of the Aid flow (current US$) in Heavily indebted poor countries in 1997 to that in 1998?
Give a very brief answer. 0.89. What is the ratio of the Aid flow (current US$) in Cabo Verde in 1997 to that in 1998?
Keep it short and to the point. 0.04. What is the ratio of the Aid flow (current US$) in Tunisia in 1997 to that in 1998?
Give a very brief answer. 1.78. What is the ratio of the Aid flow (current US$) of Europe(all income levels) in 1997 to that in 1999?
Keep it short and to the point. 0.1. What is the ratio of the Aid flow (current US$) of Heavily indebted poor countries in 1997 to that in 1999?
Your response must be concise. 1.15. What is the ratio of the Aid flow (current US$) in Cabo Verde in 1997 to that in 1999?
Make the answer very short. 0.03. What is the ratio of the Aid flow (current US$) in Tunisia in 1997 to that in 1999?
Offer a terse response. 8.61. What is the ratio of the Aid flow (current US$) in Europe(all income levels) in 1998 to that in 1999?
Make the answer very short. 0.33. What is the ratio of the Aid flow (current US$) of Heavily indebted poor countries in 1998 to that in 1999?
Your answer should be very brief. 1.3. What is the ratio of the Aid flow (current US$) of Cabo Verde in 1998 to that in 1999?
Provide a short and direct response. 0.82. What is the ratio of the Aid flow (current US$) in Tunisia in 1998 to that in 1999?
Ensure brevity in your answer.  4.84. What is the difference between the highest and the second highest Aid flow (current US$) in Europe(all income levels)?
Offer a very short reply. 6.43e+07. What is the difference between the highest and the second highest Aid flow (current US$) of Heavily indebted poor countries?
Offer a very short reply. 3.83e+07. What is the difference between the highest and the second highest Aid flow (current US$) in Cabo Verde?
Keep it short and to the point. 3.10e+05. What is the difference between the highest and the second highest Aid flow (current US$) in Tunisia?
Your response must be concise. 6.00e+05. What is the difference between the highest and the lowest Aid flow (current US$) in Europe(all income levels)?
Keep it short and to the point. 9.43e+07. What is the difference between the highest and the lowest Aid flow (current US$) of Heavily indebted poor countries?
Provide a succinct answer. 1.22e+08. What is the difference between the highest and the lowest Aid flow (current US$) of Cabo Verde?
Offer a terse response. 1.63e+06. What is the difference between the highest and the lowest Aid flow (current US$) of Tunisia?
Offer a terse response. 8.60e+06. 